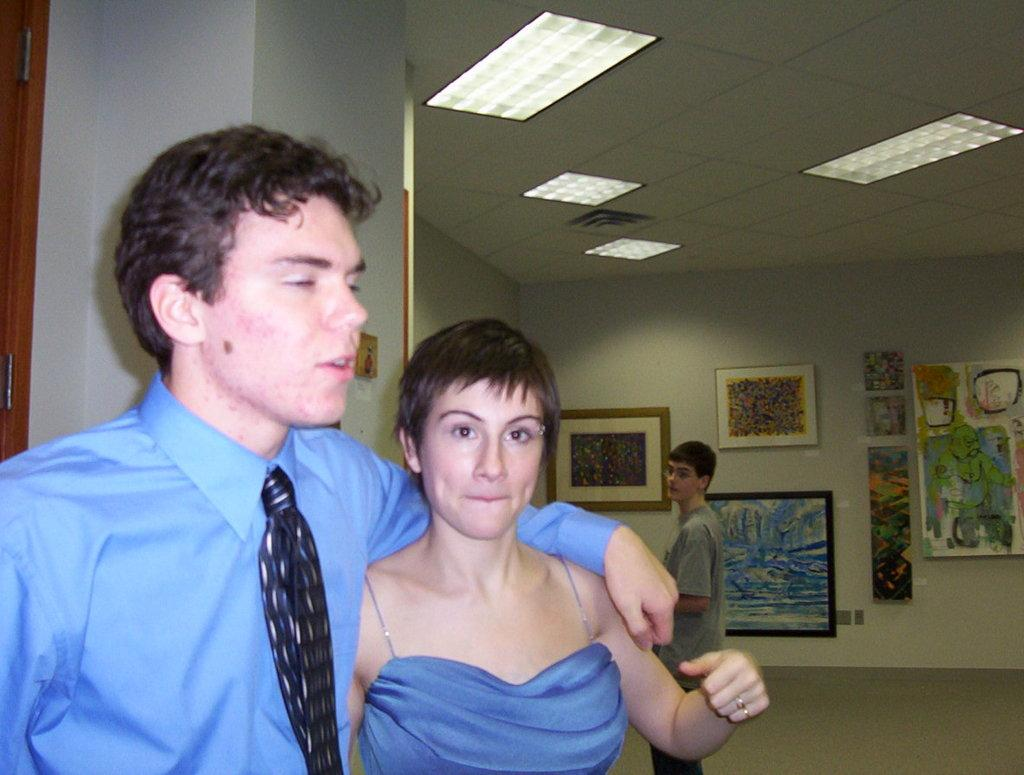How many people are present in the image? There are three persons in the image. What can be seen in the image besides the people? There are lights, frames, a wall, and a ceiling in the image. What type of stem can be seen growing from the wall in the image? There is no stem growing from the wall in the image. What town or harbor is visible in the image? There is no town or harbor present in the image. 